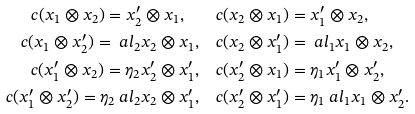Convert formula to latex. <formula><loc_0><loc_0><loc_500><loc_500>c ( x _ { 1 } \otimes x _ { 2 } ) = x ^ { \prime } _ { 2 } \otimes x _ { 1 } , \quad & c ( x _ { 2 } \otimes x _ { 1 } ) = x ^ { \prime } _ { 1 } \otimes x _ { 2 } , \\ c ( x _ { 1 } \otimes x ^ { \prime } _ { 2 } ) = \ a l _ { 2 } x _ { 2 } \otimes x _ { 1 } , \quad & c ( x _ { 2 } \otimes x ^ { \prime } _ { 1 } ) = \ a l _ { 1 } x _ { 1 } \otimes x _ { 2 } , \\ c ( x ^ { \prime } _ { 1 } \otimes x _ { 2 } ) = \eta _ { 2 } x ^ { \prime } _ { 2 } \otimes x ^ { \prime } _ { 1 } , \quad & c ( x ^ { \prime } _ { 2 } \otimes x _ { 1 } ) = \eta _ { 1 } x ^ { \prime } _ { 1 } \otimes x ^ { \prime } _ { 2 } , \\ c ( x ^ { \prime } _ { 1 } \otimes x ^ { \prime } _ { 2 } ) = \eta _ { 2 } \ a l _ { 2 } x _ { 2 } \otimes x ^ { \prime } _ { 1 } , \quad & c ( x ^ { \prime } _ { 2 } \otimes x ^ { \prime } _ { 1 } ) = \eta _ { 1 } \ a l _ { 1 } x _ { 1 } \otimes x ^ { \prime } _ { 2 } .</formula> 